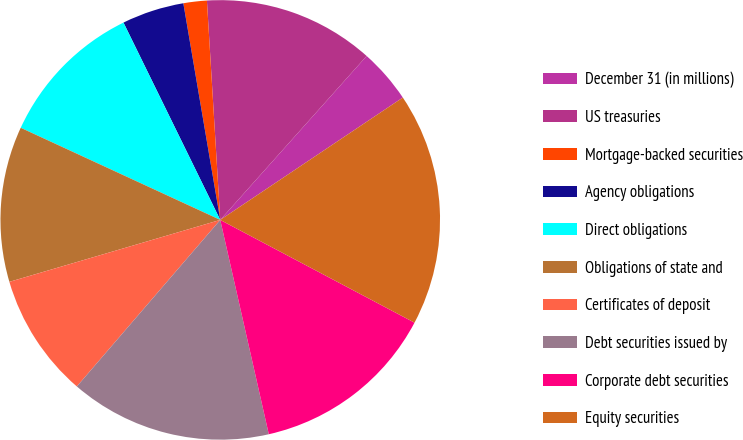Convert chart. <chart><loc_0><loc_0><loc_500><loc_500><pie_chart><fcel>December 31 (in millions)<fcel>US treasuries<fcel>Mortgage-backed securities<fcel>Agency obligations<fcel>Direct obligations<fcel>Obligations of state and<fcel>Certificates of deposit<fcel>Debt securities issued by<fcel>Corporate debt securities<fcel>Equity securities<nl><fcel>4.0%<fcel>12.57%<fcel>1.72%<fcel>4.57%<fcel>10.86%<fcel>11.43%<fcel>9.14%<fcel>14.86%<fcel>13.71%<fcel>17.14%<nl></chart> 